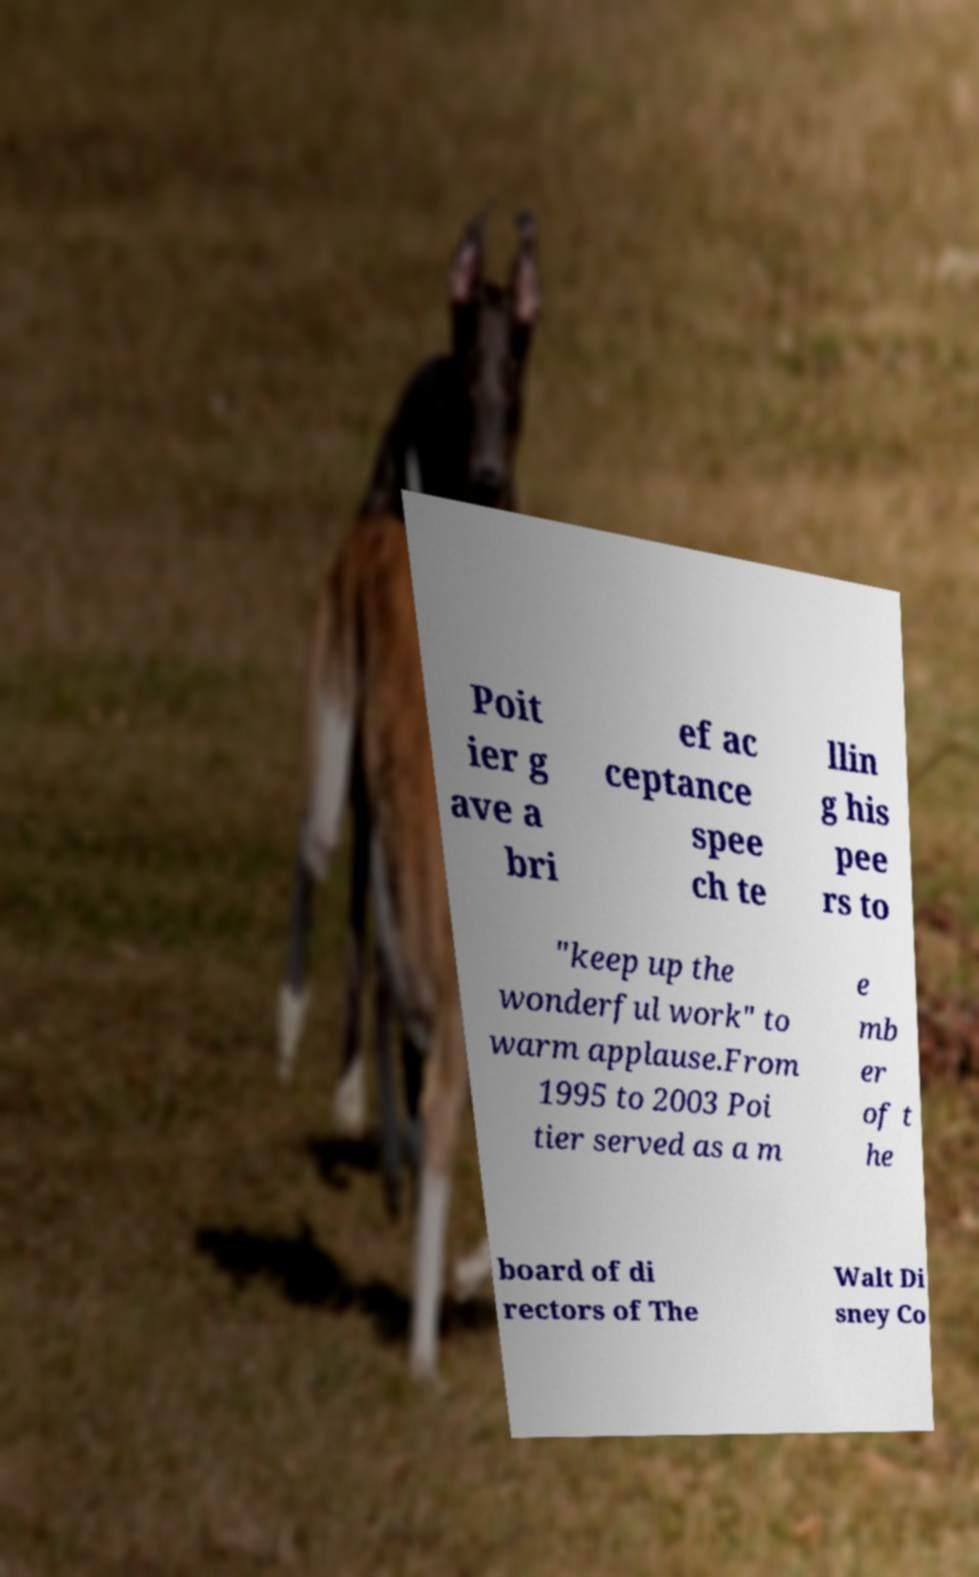Can you accurately transcribe the text from the provided image for me? Poit ier g ave a bri ef ac ceptance spee ch te llin g his pee rs to "keep up the wonderful work" to warm applause.From 1995 to 2003 Poi tier served as a m e mb er of t he board of di rectors of The Walt Di sney Co 